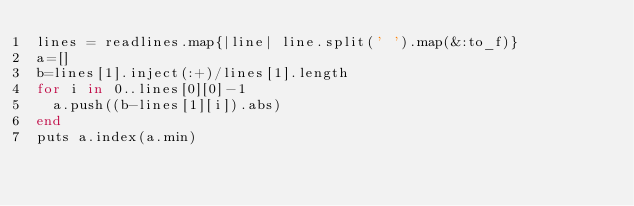Convert code to text. <code><loc_0><loc_0><loc_500><loc_500><_Ruby_>lines = readlines.map{|line| line.split(' ').map(&:to_f)}
a=[]
b=lines[1].inject(:+)/lines[1].length
for i in 0..lines[0][0]-1
  a.push((b-lines[1][i]).abs)
end
puts a.index(a.min)</code> 